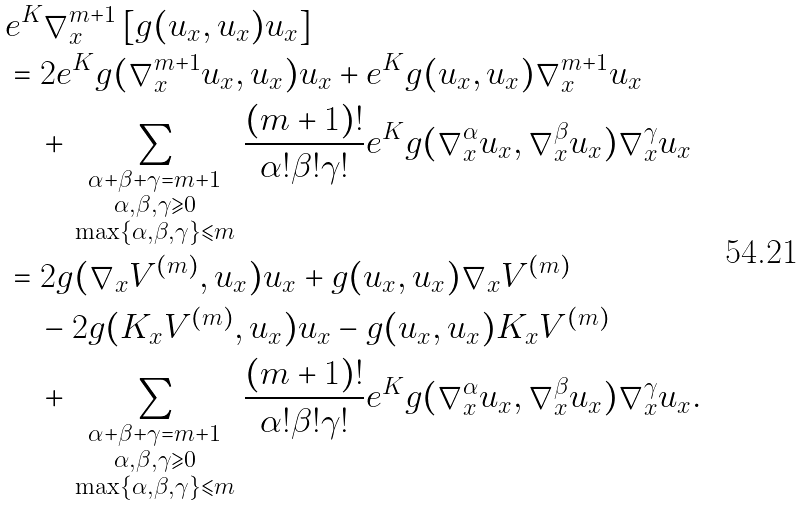Convert formula to latex. <formula><loc_0><loc_0><loc_500><loc_500>& e ^ { K } \nabla _ { x } ^ { m + 1 } \left [ g ( u _ { x } , u _ { x } ) u _ { x } \right ] \\ & = 2 e ^ { K } g ( \nabla _ { x } ^ { m + 1 } u _ { x } , u _ { x } ) u _ { x } + e ^ { K } g ( u _ { x } , u _ { x } ) \nabla _ { x } ^ { m + 1 } u _ { x } \\ & \quad + \sum _ { \begin{smallmatrix} \alpha + \beta + \gamma = m + 1 \\ \alpha , \beta , \gamma \geqslant 0 \\ \max \{ \alpha , \beta , \gamma \} \leqslant m \end{smallmatrix} } \frac { ( m + 1 ) ! } { \alpha ! \beta ! \gamma ! } e ^ { K } g ( \nabla _ { x } ^ { \alpha } u _ { x } , \nabla _ { x } ^ { \beta } u _ { x } ) \nabla _ { x } ^ { \gamma } u _ { x } \\ & = 2 g ( \nabla _ { x } V ^ { ( m ) } , u _ { x } ) u _ { x } + g ( u _ { x } , u _ { x } ) \nabla _ { x } V ^ { ( m ) } \\ & \quad - 2 g ( K _ { x } V ^ { ( m ) } , u _ { x } ) u _ { x } - g ( u _ { x } , u _ { x } ) K _ { x } V ^ { ( m ) } \\ & \quad + \sum _ { \begin{smallmatrix} \alpha + \beta + \gamma = m + 1 \\ \alpha , \beta , \gamma \geqslant 0 \\ \max \{ \alpha , \beta , \gamma \} \leqslant m \end{smallmatrix} } \frac { ( m + 1 ) ! } { \alpha ! \beta ! \gamma ! } e ^ { K } g ( \nabla _ { x } ^ { \alpha } u _ { x } , \nabla _ { x } ^ { \beta } u _ { x } ) \nabla _ { x } ^ { \gamma } u _ { x } .</formula> 